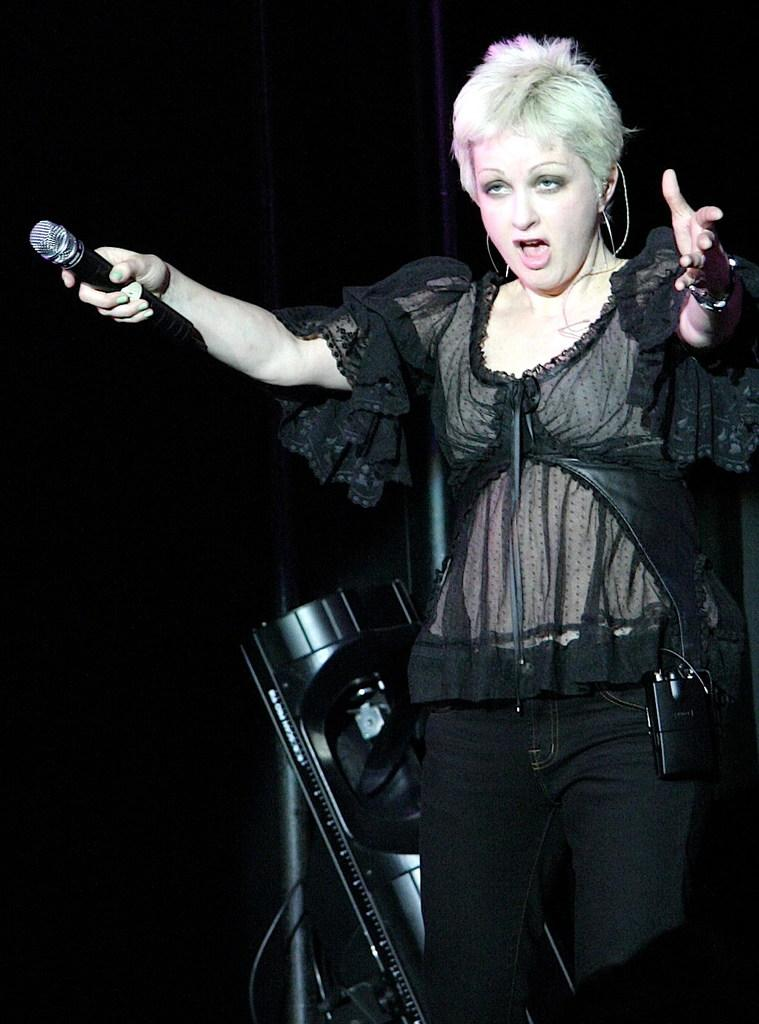Who is the main subject in the image? There is a woman in the image. What is the woman doing in the image? The woman is standing and holding a mic. What can be seen behind the woman? There is an object behind the woman. How would you describe the lighting in the image? The background of the image is dark. What type of action is the woman taking to join the frame in the image? There is no indication in the image that the woman is trying to join the frame, as she is already present and visible in the image. 